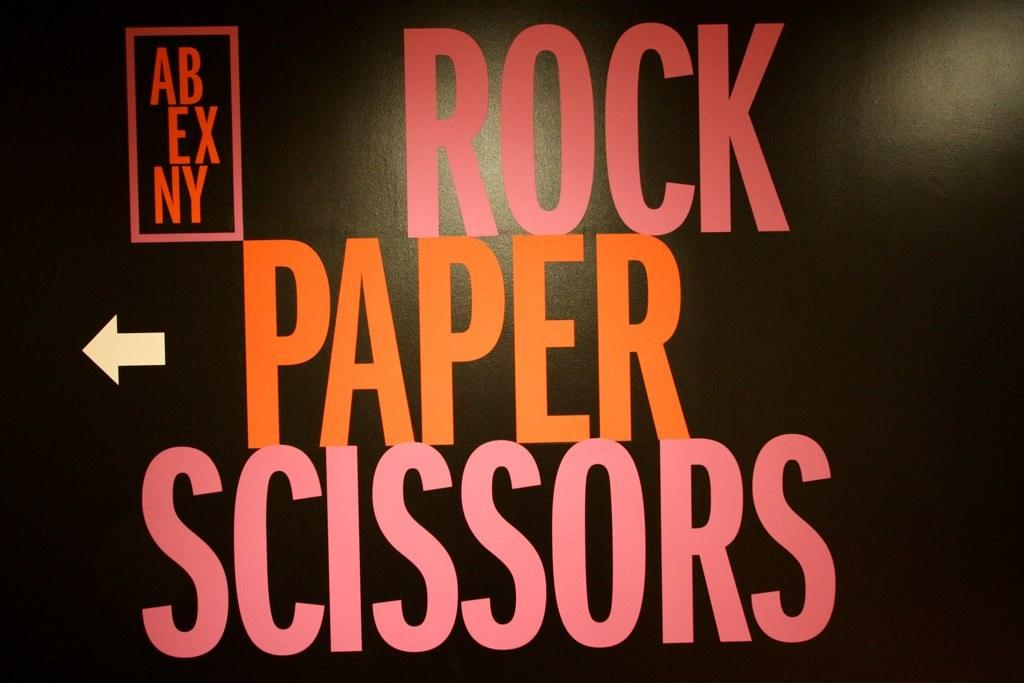<image>
Relay a brief, clear account of the picture shown. A black sign has Rock Paper Scissors in pink and orange letters. 